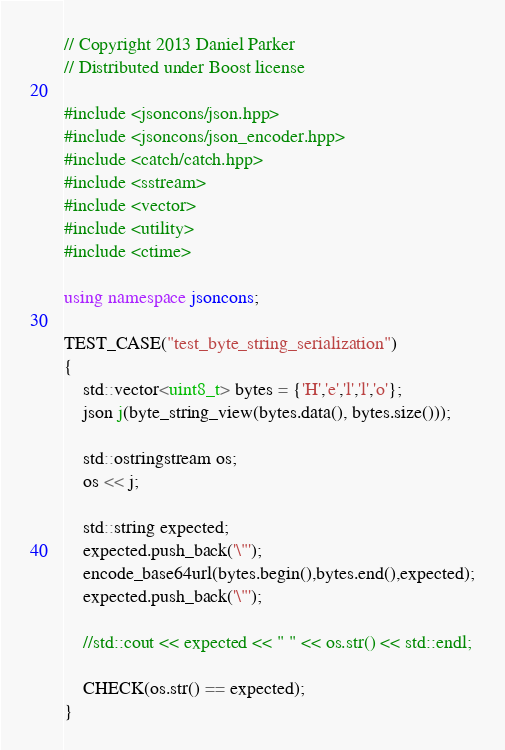Convert code to text. <code><loc_0><loc_0><loc_500><loc_500><_C++_>// Copyright 2013 Daniel Parker
// Distributed under Boost license

#include <jsoncons/json.hpp>
#include <jsoncons/json_encoder.hpp>
#include <catch/catch.hpp>
#include <sstream>
#include <vector>
#include <utility>
#include <ctime>

using namespace jsoncons;

TEST_CASE("test_byte_string_serialization")
{
    std::vector<uint8_t> bytes = {'H','e','l','l','o'};
    json j(byte_string_view(bytes.data(), bytes.size()));

    std::ostringstream os;
    os << j;

    std::string expected; 
    expected.push_back('\"');
    encode_base64url(bytes.begin(),bytes.end(),expected);
    expected.push_back('\"');

    //std::cout << expected << " " << os.str() << std::endl;

    CHECK(os.str() == expected);
}

</code> 